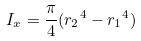<formula> <loc_0><loc_0><loc_500><loc_500>I _ { x } = \frac { \pi } { 4 } ( { r _ { 2 } } ^ { 4 } - { r _ { 1 } } ^ { 4 } )</formula> 